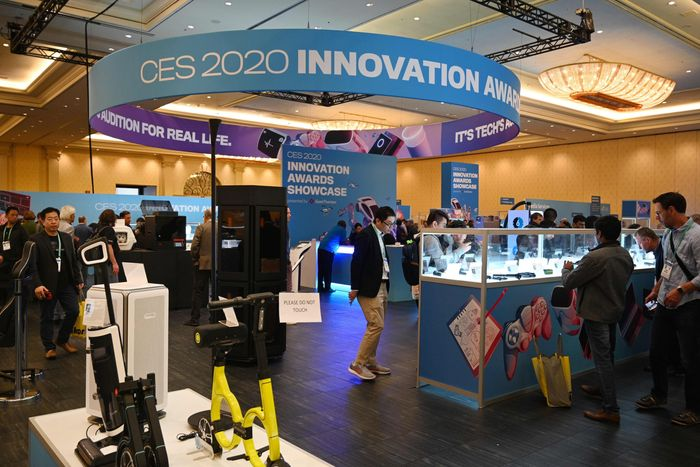What do you see The image shows an indoor event space with several people looking at exhibits. Prominently displayed at the top is a sign that reads "CES 2020 INNOVATION AWARDS," indicating that this photo was taken at the Consumer Electronics Show (CES) in 2020, which is an annual trade show organized by the Consumer Technology Association (CTA) showcasing new products and technologies in the consumer electronics industry.

There are various technology products presented on stands, and attendees are engaged in observing and interacting with these items. Some attendees are standing and looking at the displays, while others appear to be in conversation or moving around the space. The atmosphere suggests a showcase or exhibition area where innovative products are being highlighted and celebrated. 